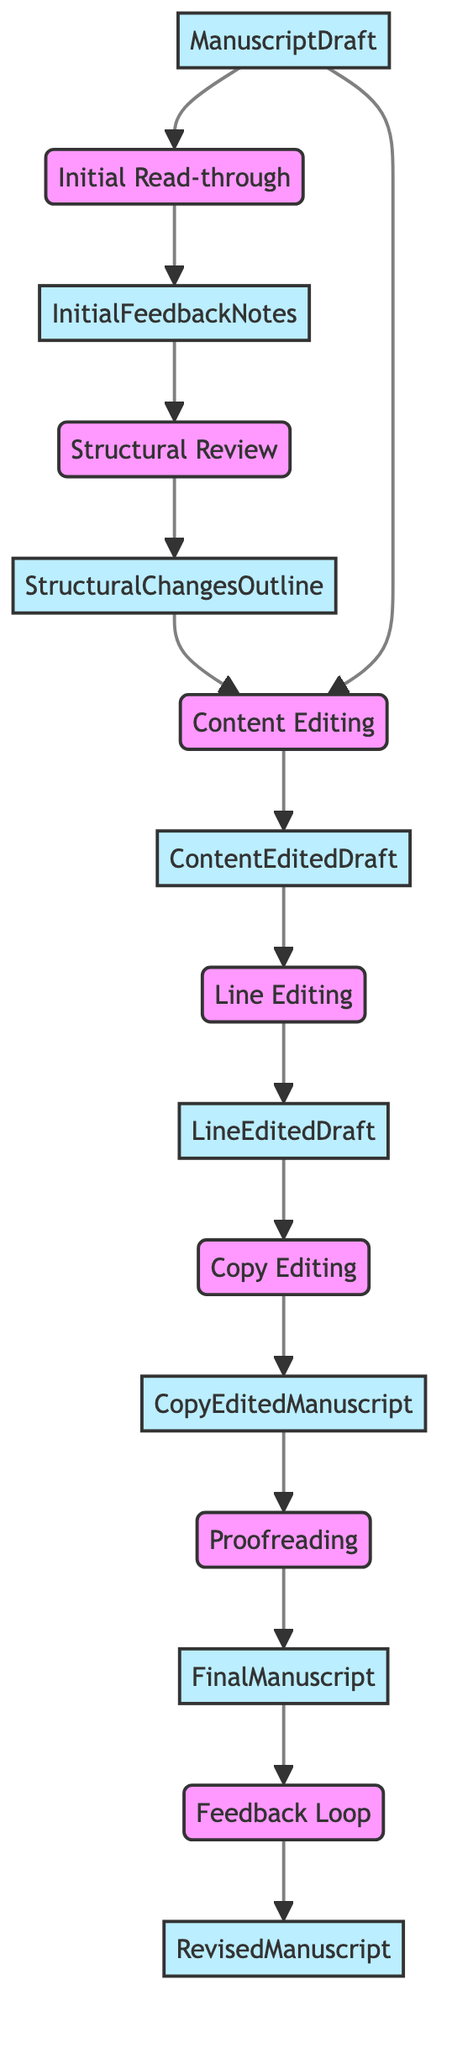What is the first action in the editing process? The flowchart begins with the node labeled "Initial Read-through," which indicates that this is the first step in the editing and revising process for the manuscript.
Answer: Initial Read-through How many major steps are there in the editing process? The flowchart outlines a total of seven major steps, from "Initial Read-through" to "Feedback Loop."
Answer: 7 What is the output of the "Line Editing" step? The output of the "Line Editing" step is indicated as "LineEditedDraft," which shows that this is the result of this particular action within the editing process.
Answer: LineEditedDraft Which step follows directly after "Copy Editing"? The "Proofreading" step follows directly after the "Copy Editing" step, indicating the progression of the tasks involved in the editing process.
Answer: Proofreading What inputs are needed for the "Content Editing" step? The "Content Editing" step requires two inputs: "StructuralChangesOutline" and "ManuscriptDraft," as these are shown leading into this step in the flowchart.
Answer: StructuralChangesOutline, ManuscriptDraft What is the final output of the entire process? The final output after all steps in the process as depicted in the flowchart is the "RevisedManuscript," suggesting that this is the end product following revisions.
Answer: RevisedManuscript Which step focuses on grammar and punctuation? "Copy Editing" focuses specifically on checking for grammar, punctuation, and syntax errors, according to the descriptions in the flowchart.
Answer: Copy Editing What indicates the need for adjustments in the manuscript? The "Feedback Loop" step indicates the need for adjustments as it involves soliciting feedback from beta readers or critique partners to make necessary changes.
Answer: Feedback Loop What is the purpose of the "Initial Read-through"? The purpose of the "Initial Read-through" is to understand the overall structure and flow of the manuscript, which is necessary before further editing steps can take place.
Answer: Understand overall structure and flow of the manuscript 